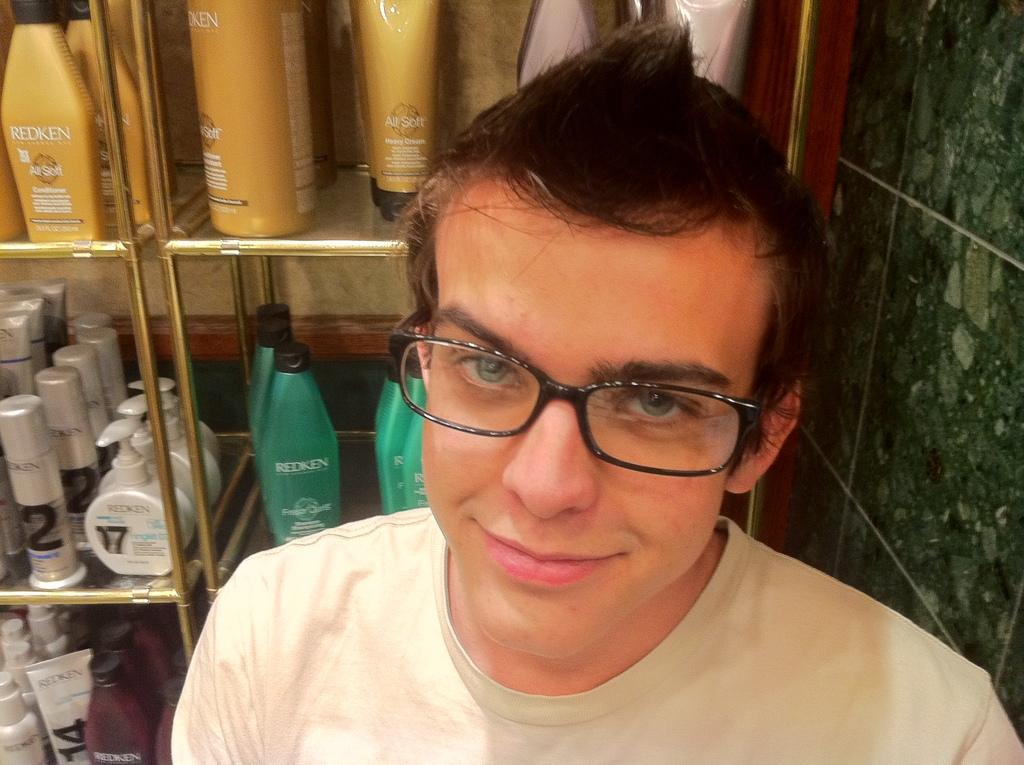<image>
Provide a brief description of the given image. A man with glasses stands in front of a shelf with Redken hair products in various bottles 